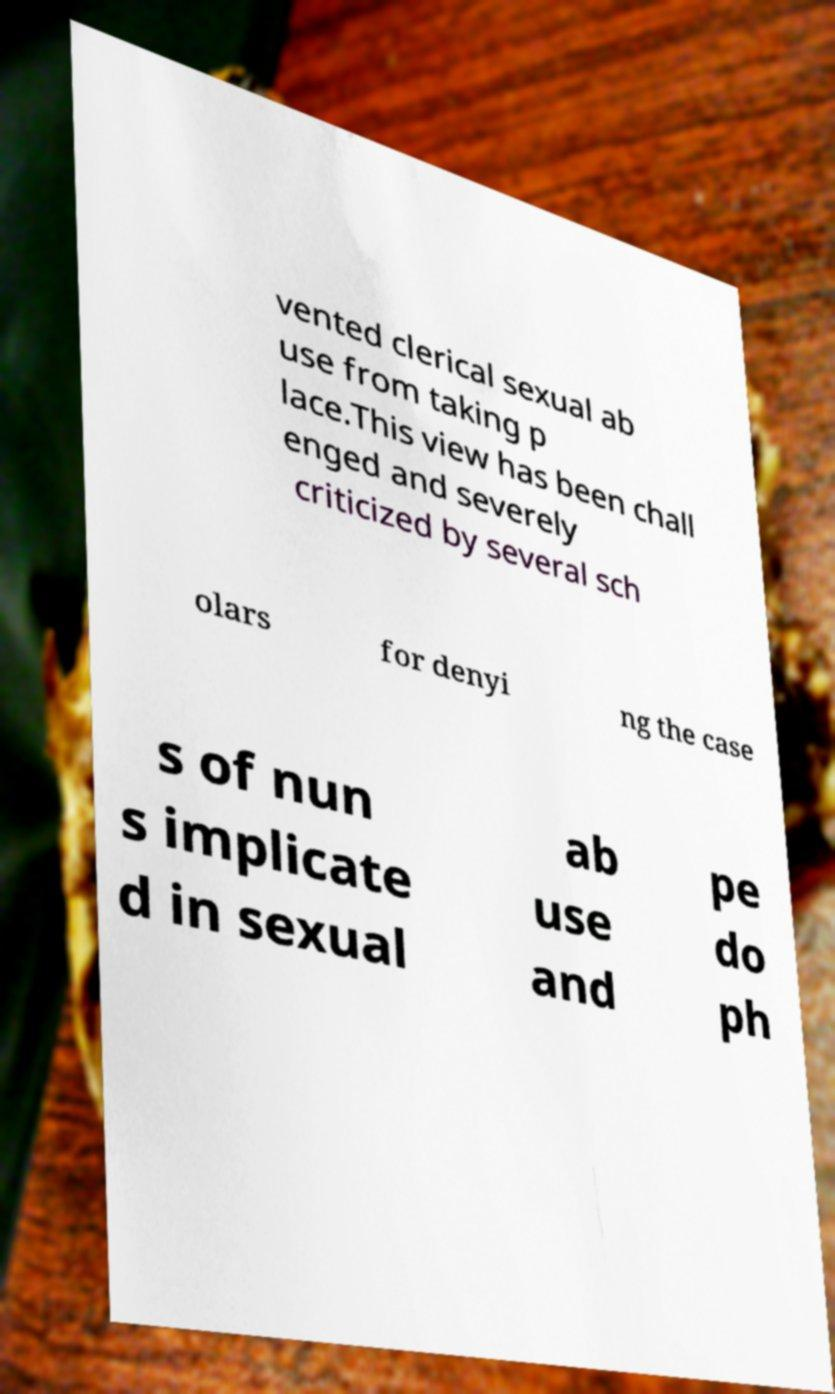Can you accurately transcribe the text from the provided image for me? vented clerical sexual ab use from taking p lace.This view has been chall enged and severely criticized by several sch olars for denyi ng the case s of nun s implicate d in sexual ab use and pe do ph 